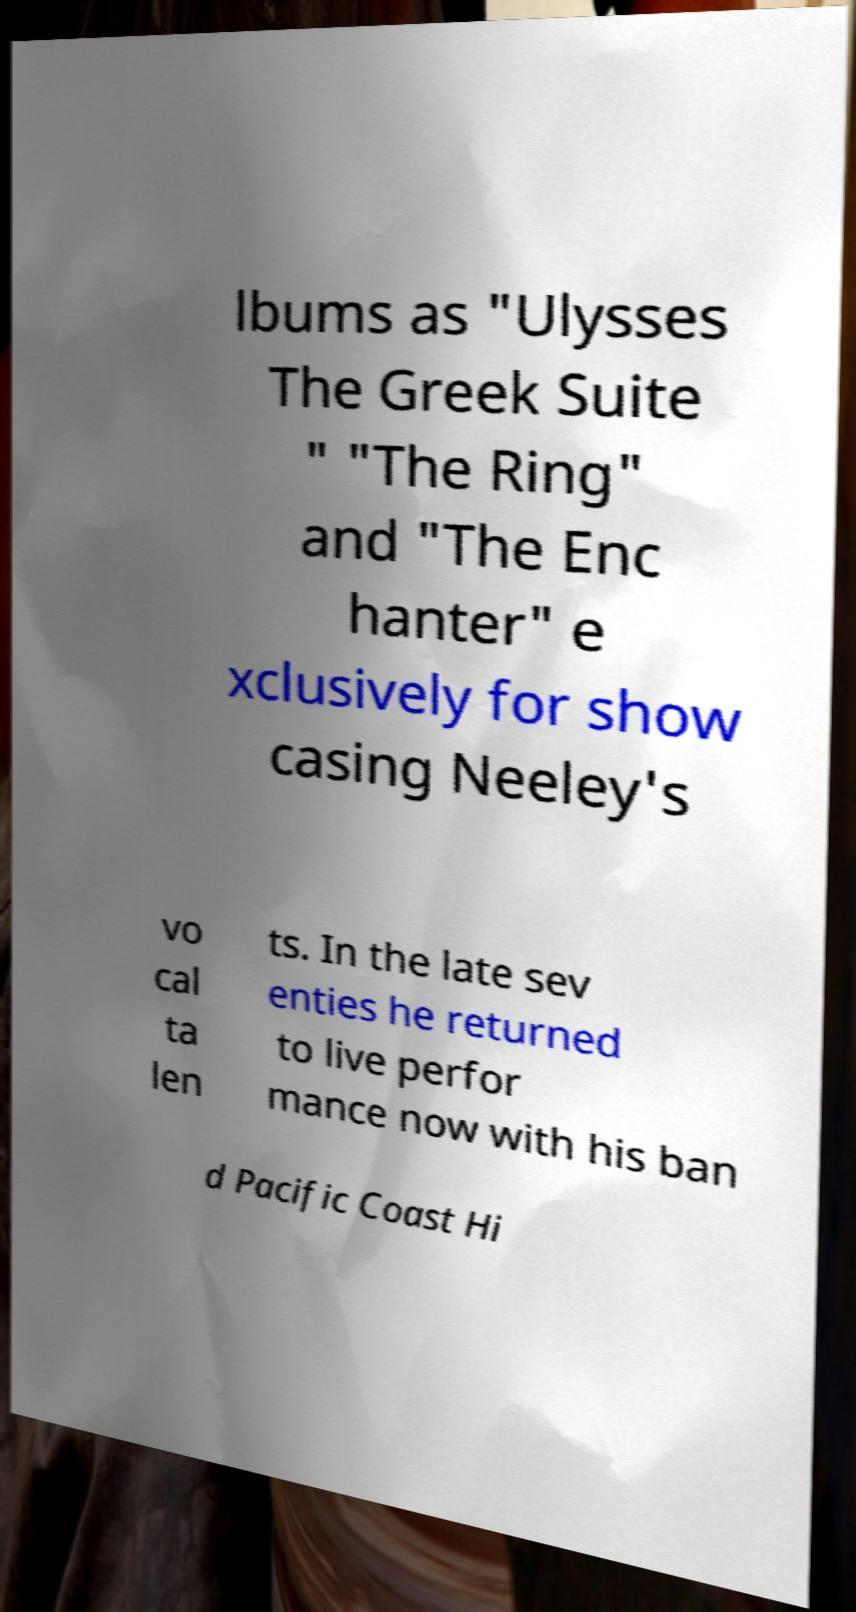Please identify and transcribe the text found in this image. lbums as "Ulysses The Greek Suite " "The Ring" and "The Enc hanter" e xclusively for show casing Neeley's vo cal ta len ts. In the late sev enties he returned to live perfor mance now with his ban d Pacific Coast Hi 